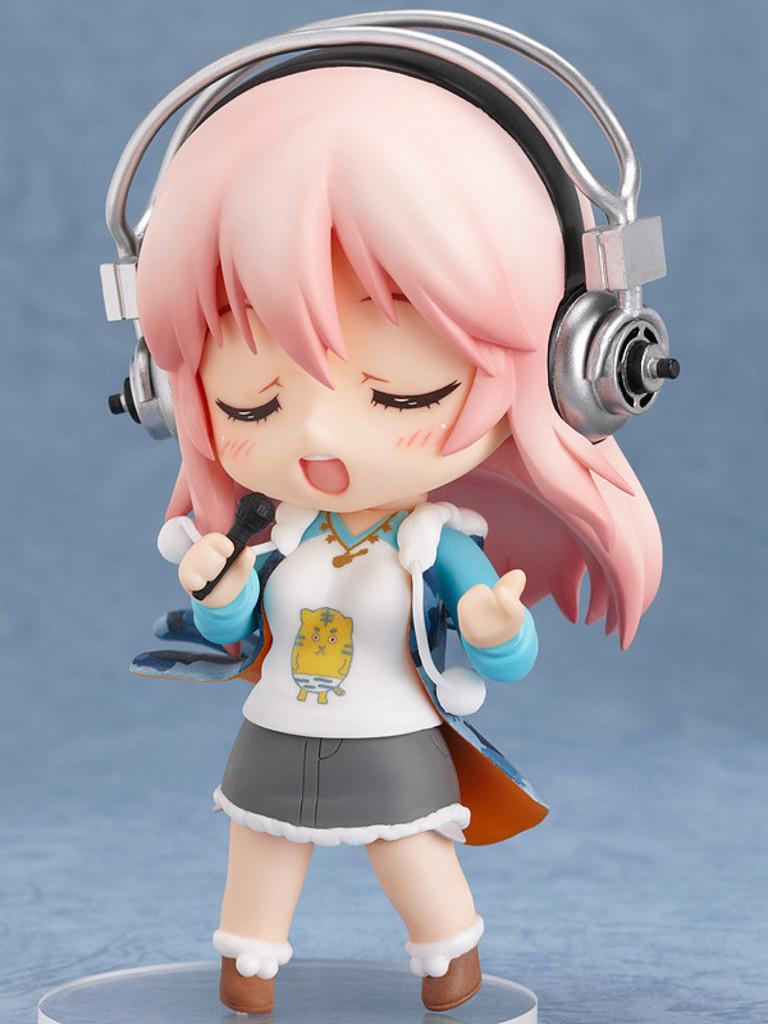Who is the main subject in the image? There is a girl in the image. What is the girl holding in the image? The girl is holding a microphone. What else is the girl wearing in the image? The girl is wearing a headset. What might the girl be doing in the image? It appears that the girl is singing. What type of brush is the girl using to paint in the image? There is no brush present in the image, and the girl is not painting; she is singing. 